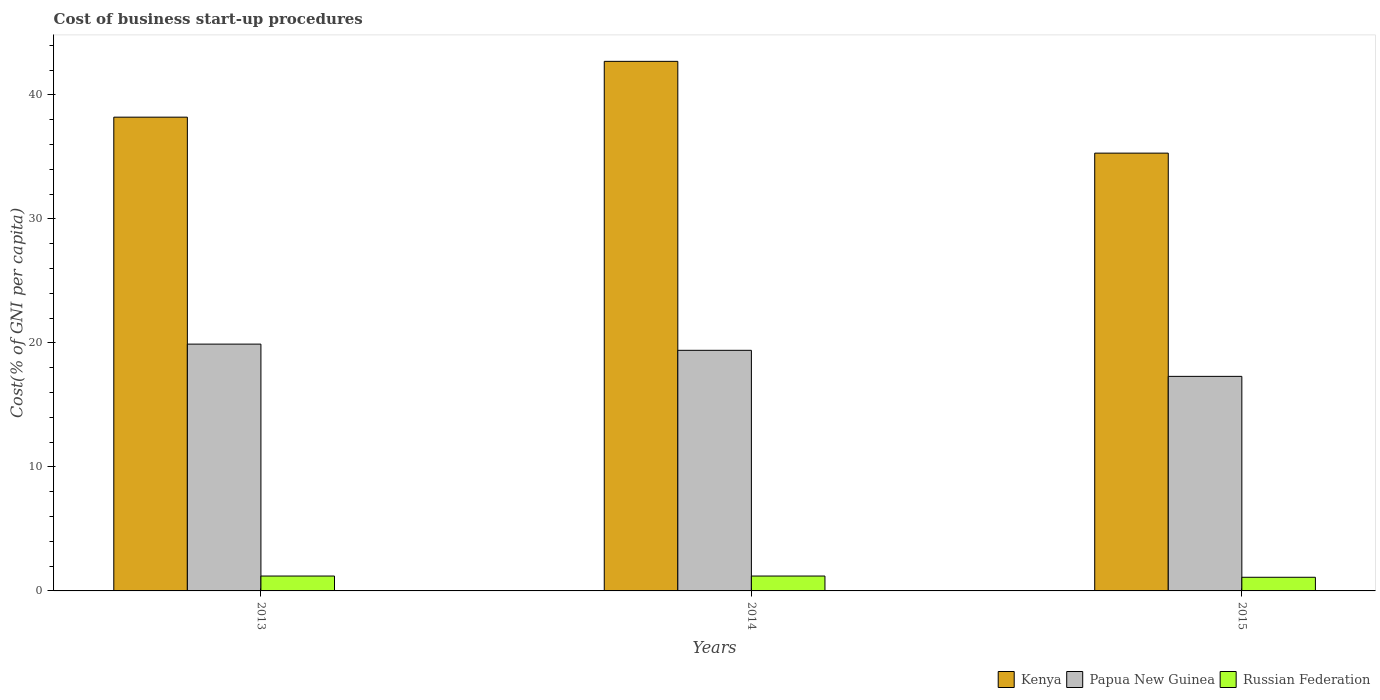How many different coloured bars are there?
Your answer should be compact. 3. How many groups of bars are there?
Keep it short and to the point. 3. Are the number of bars on each tick of the X-axis equal?
Offer a terse response. Yes. How many bars are there on the 1st tick from the left?
Offer a terse response. 3. How many bars are there on the 3rd tick from the right?
Your answer should be very brief. 3. What is the label of the 2nd group of bars from the left?
Your answer should be compact. 2014. In how many cases, is the number of bars for a given year not equal to the number of legend labels?
Keep it short and to the point. 0. What is the cost of business start-up procedures in Kenya in 2014?
Offer a very short reply. 42.7. Across all years, what is the maximum cost of business start-up procedures in Kenya?
Provide a short and direct response. 42.7. Across all years, what is the minimum cost of business start-up procedures in Kenya?
Offer a terse response. 35.3. In which year was the cost of business start-up procedures in Russian Federation minimum?
Offer a very short reply. 2015. What is the difference between the cost of business start-up procedures in Kenya in 2013 and that in 2015?
Your response must be concise. 2.9. What is the difference between the cost of business start-up procedures in Russian Federation in 2014 and the cost of business start-up procedures in Papua New Guinea in 2013?
Your response must be concise. -18.7. What is the average cost of business start-up procedures in Papua New Guinea per year?
Provide a succinct answer. 18.87. In the year 2014, what is the difference between the cost of business start-up procedures in Russian Federation and cost of business start-up procedures in Kenya?
Your response must be concise. -41.5. What is the ratio of the cost of business start-up procedures in Kenya in 2013 to that in 2014?
Provide a succinct answer. 0.89. Is the difference between the cost of business start-up procedures in Russian Federation in 2013 and 2015 greater than the difference between the cost of business start-up procedures in Kenya in 2013 and 2015?
Your answer should be very brief. No. What is the difference between the highest and the lowest cost of business start-up procedures in Papua New Guinea?
Ensure brevity in your answer.  2.6. In how many years, is the cost of business start-up procedures in Papua New Guinea greater than the average cost of business start-up procedures in Papua New Guinea taken over all years?
Offer a terse response. 2. What does the 3rd bar from the left in 2015 represents?
Your answer should be very brief. Russian Federation. What does the 3rd bar from the right in 2013 represents?
Your response must be concise. Kenya. Is it the case that in every year, the sum of the cost of business start-up procedures in Russian Federation and cost of business start-up procedures in Kenya is greater than the cost of business start-up procedures in Papua New Guinea?
Provide a short and direct response. Yes. Are all the bars in the graph horizontal?
Make the answer very short. No. How many years are there in the graph?
Your answer should be very brief. 3. What is the difference between two consecutive major ticks on the Y-axis?
Provide a succinct answer. 10. Are the values on the major ticks of Y-axis written in scientific E-notation?
Give a very brief answer. No. Does the graph contain grids?
Ensure brevity in your answer.  No. Where does the legend appear in the graph?
Offer a terse response. Bottom right. How many legend labels are there?
Your answer should be compact. 3. How are the legend labels stacked?
Your response must be concise. Horizontal. What is the title of the graph?
Your answer should be compact. Cost of business start-up procedures. What is the label or title of the X-axis?
Give a very brief answer. Years. What is the label or title of the Y-axis?
Your answer should be very brief. Cost(% of GNI per capita). What is the Cost(% of GNI per capita) of Kenya in 2013?
Offer a terse response. 38.2. What is the Cost(% of GNI per capita) of Papua New Guinea in 2013?
Offer a terse response. 19.9. What is the Cost(% of GNI per capita) in Kenya in 2014?
Provide a short and direct response. 42.7. What is the Cost(% of GNI per capita) in Papua New Guinea in 2014?
Give a very brief answer. 19.4. What is the Cost(% of GNI per capita) of Kenya in 2015?
Ensure brevity in your answer.  35.3. What is the Cost(% of GNI per capita) of Papua New Guinea in 2015?
Offer a terse response. 17.3. What is the Cost(% of GNI per capita) of Russian Federation in 2015?
Give a very brief answer. 1.1. Across all years, what is the maximum Cost(% of GNI per capita) of Kenya?
Your answer should be compact. 42.7. Across all years, what is the maximum Cost(% of GNI per capita) of Papua New Guinea?
Offer a terse response. 19.9. Across all years, what is the minimum Cost(% of GNI per capita) in Kenya?
Offer a terse response. 35.3. What is the total Cost(% of GNI per capita) in Kenya in the graph?
Your answer should be very brief. 116.2. What is the total Cost(% of GNI per capita) of Papua New Guinea in the graph?
Your answer should be compact. 56.6. What is the difference between the Cost(% of GNI per capita) in Kenya in 2013 and that in 2014?
Provide a short and direct response. -4.5. What is the difference between the Cost(% of GNI per capita) in Papua New Guinea in 2013 and that in 2015?
Provide a succinct answer. 2.6. What is the difference between the Cost(% of GNI per capita) of Russian Federation in 2013 and that in 2015?
Make the answer very short. 0.1. What is the difference between the Cost(% of GNI per capita) of Papua New Guinea in 2014 and that in 2015?
Your response must be concise. 2.1. What is the difference between the Cost(% of GNI per capita) in Kenya in 2013 and the Cost(% of GNI per capita) in Papua New Guinea in 2015?
Your response must be concise. 20.9. What is the difference between the Cost(% of GNI per capita) in Kenya in 2013 and the Cost(% of GNI per capita) in Russian Federation in 2015?
Offer a terse response. 37.1. What is the difference between the Cost(% of GNI per capita) of Papua New Guinea in 2013 and the Cost(% of GNI per capita) of Russian Federation in 2015?
Offer a terse response. 18.8. What is the difference between the Cost(% of GNI per capita) in Kenya in 2014 and the Cost(% of GNI per capita) in Papua New Guinea in 2015?
Your answer should be compact. 25.4. What is the difference between the Cost(% of GNI per capita) of Kenya in 2014 and the Cost(% of GNI per capita) of Russian Federation in 2015?
Your response must be concise. 41.6. What is the difference between the Cost(% of GNI per capita) in Papua New Guinea in 2014 and the Cost(% of GNI per capita) in Russian Federation in 2015?
Give a very brief answer. 18.3. What is the average Cost(% of GNI per capita) of Kenya per year?
Provide a succinct answer. 38.73. What is the average Cost(% of GNI per capita) of Papua New Guinea per year?
Keep it short and to the point. 18.87. In the year 2014, what is the difference between the Cost(% of GNI per capita) in Kenya and Cost(% of GNI per capita) in Papua New Guinea?
Ensure brevity in your answer.  23.3. In the year 2014, what is the difference between the Cost(% of GNI per capita) in Kenya and Cost(% of GNI per capita) in Russian Federation?
Keep it short and to the point. 41.5. In the year 2014, what is the difference between the Cost(% of GNI per capita) of Papua New Guinea and Cost(% of GNI per capita) of Russian Federation?
Offer a very short reply. 18.2. In the year 2015, what is the difference between the Cost(% of GNI per capita) in Kenya and Cost(% of GNI per capita) in Russian Federation?
Provide a short and direct response. 34.2. What is the ratio of the Cost(% of GNI per capita) in Kenya in 2013 to that in 2014?
Your response must be concise. 0.89. What is the ratio of the Cost(% of GNI per capita) in Papua New Guinea in 2013 to that in 2014?
Ensure brevity in your answer.  1.03. What is the ratio of the Cost(% of GNI per capita) in Kenya in 2013 to that in 2015?
Make the answer very short. 1.08. What is the ratio of the Cost(% of GNI per capita) of Papua New Guinea in 2013 to that in 2015?
Make the answer very short. 1.15. What is the ratio of the Cost(% of GNI per capita) in Russian Federation in 2013 to that in 2015?
Offer a terse response. 1.09. What is the ratio of the Cost(% of GNI per capita) of Kenya in 2014 to that in 2015?
Your answer should be very brief. 1.21. What is the ratio of the Cost(% of GNI per capita) of Papua New Guinea in 2014 to that in 2015?
Ensure brevity in your answer.  1.12. What is the ratio of the Cost(% of GNI per capita) of Russian Federation in 2014 to that in 2015?
Your response must be concise. 1.09. What is the difference between the highest and the second highest Cost(% of GNI per capita) of Papua New Guinea?
Provide a succinct answer. 0.5. What is the difference between the highest and the second highest Cost(% of GNI per capita) in Russian Federation?
Keep it short and to the point. 0. What is the difference between the highest and the lowest Cost(% of GNI per capita) in Kenya?
Ensure brevity in your answer.  7.4. What is the difference between the highest and the lowest Cost(% of GNI per capita) in Papua New Guinea?
Provide a succinct answer. 2.6. 